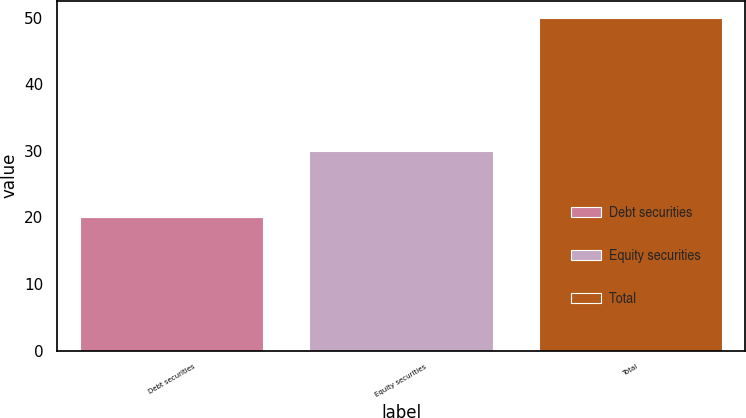Convert chart to OTSL. <chart><loc_0><loc_0><loc_500><loc_500><bar_chart><fcel>Debt securities<fcel>Equity securities<fcel>Total<nl><fcel>20<fcel>30<fcel>50<nl></chart> 